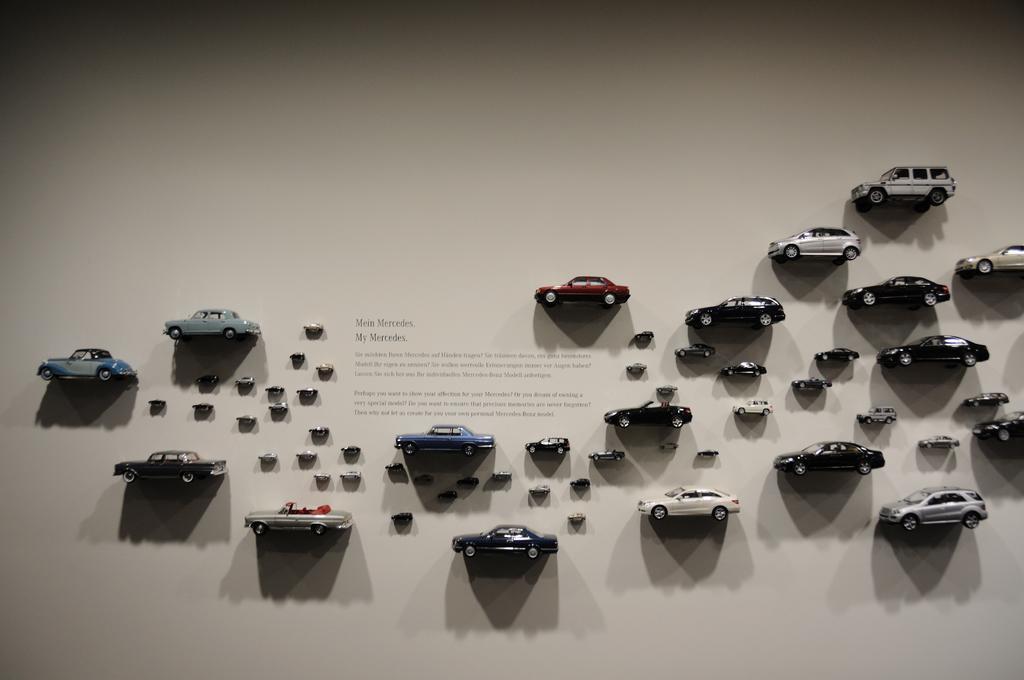Can you describe this image briefly? In this image in the center there are some toy cars which are stick to the wall, and there is a text in the center and there is a white background. 